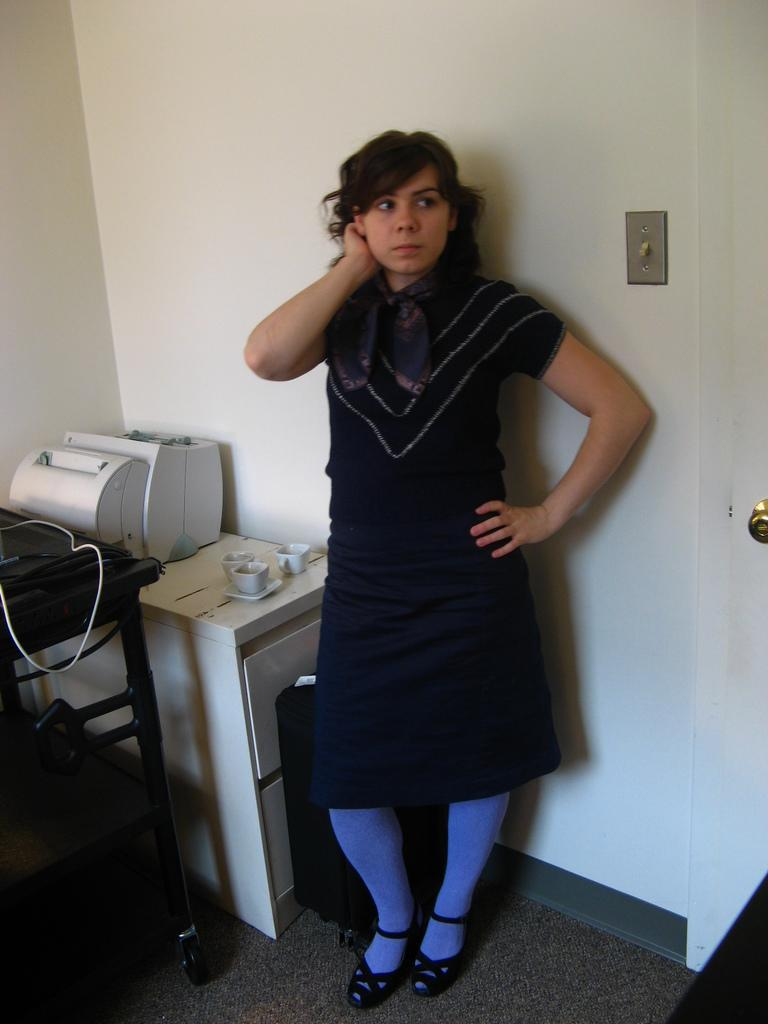Who or what is present in the image? There is a person in the image. What is the person wearing? The person is wearing a black dress. What can be seen behind the person? There is a white wall behind the person. What type of beetle can be seen crawling on the person's shoulder in the image? There is no beetle present on the person's shoulder in the image. 